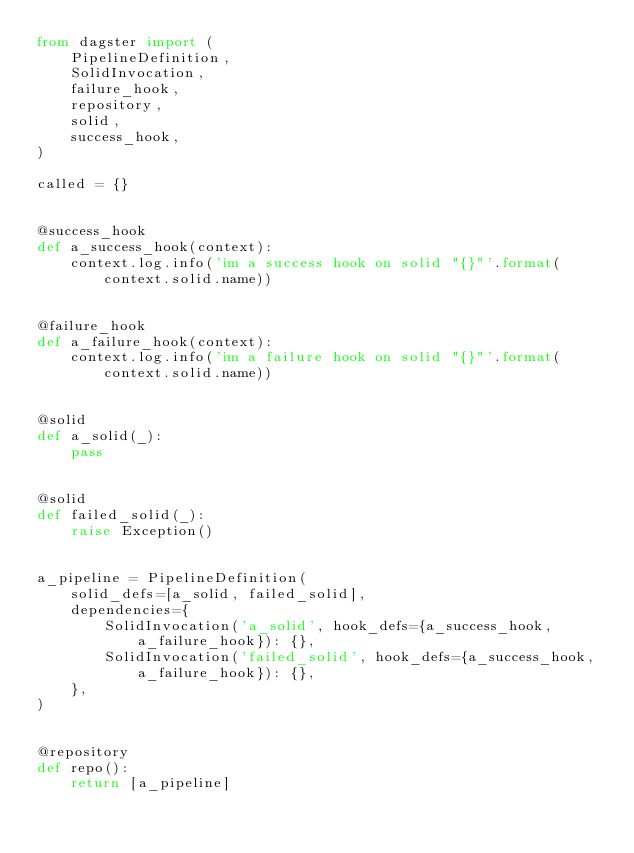Convert code to text. <code><loc_0><loc_0><loc_500><loc_500><_Python_>from dagster import (
    PipelineDefinition,
    SolidInvocation,
    failure_hook,
    repository,
    solid,
    success_hook,
)

called = {}


@success_hook
def a_success_hook(context):
    context.log.info('im a success hook on solid "{}"'.format(context.solid.name))


@failure_hook
def a_failure_hook(context):
    context.log.info('im a failure hook on solid "{}"'.format(context.solid.name))


@solid
def a_solid(_):
    pass


@solid
def failed_solid(_):
    raise Exception()


a_pipeline = PipelineDefinition(
    solid_defs=[a_solid, failed_solid],
    dependencies={
        SolidInvocation('a_solid', hook_defs={a_success_hook, a_failure_hook}): {},
        SolidInvocation('failed_solid', hook_defs={a_success_hook, a_failure_hook}): {},
    },
)


@repository
def repo():
    return [a_pipeline]
</code> 